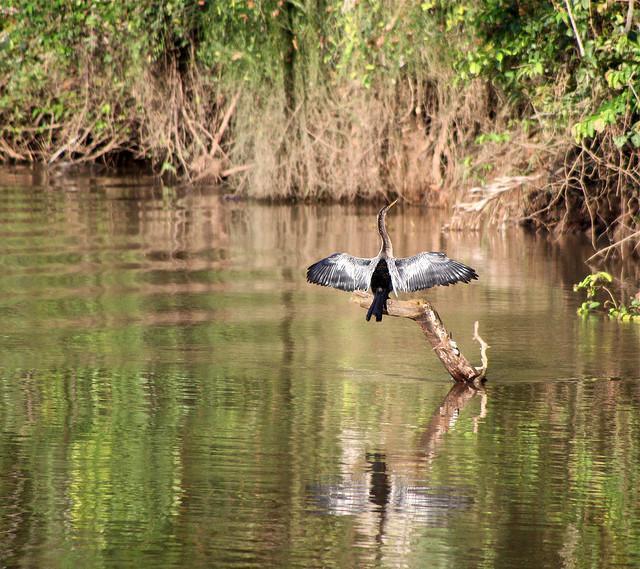How many cranes?
Give a very brief answer. 1. 